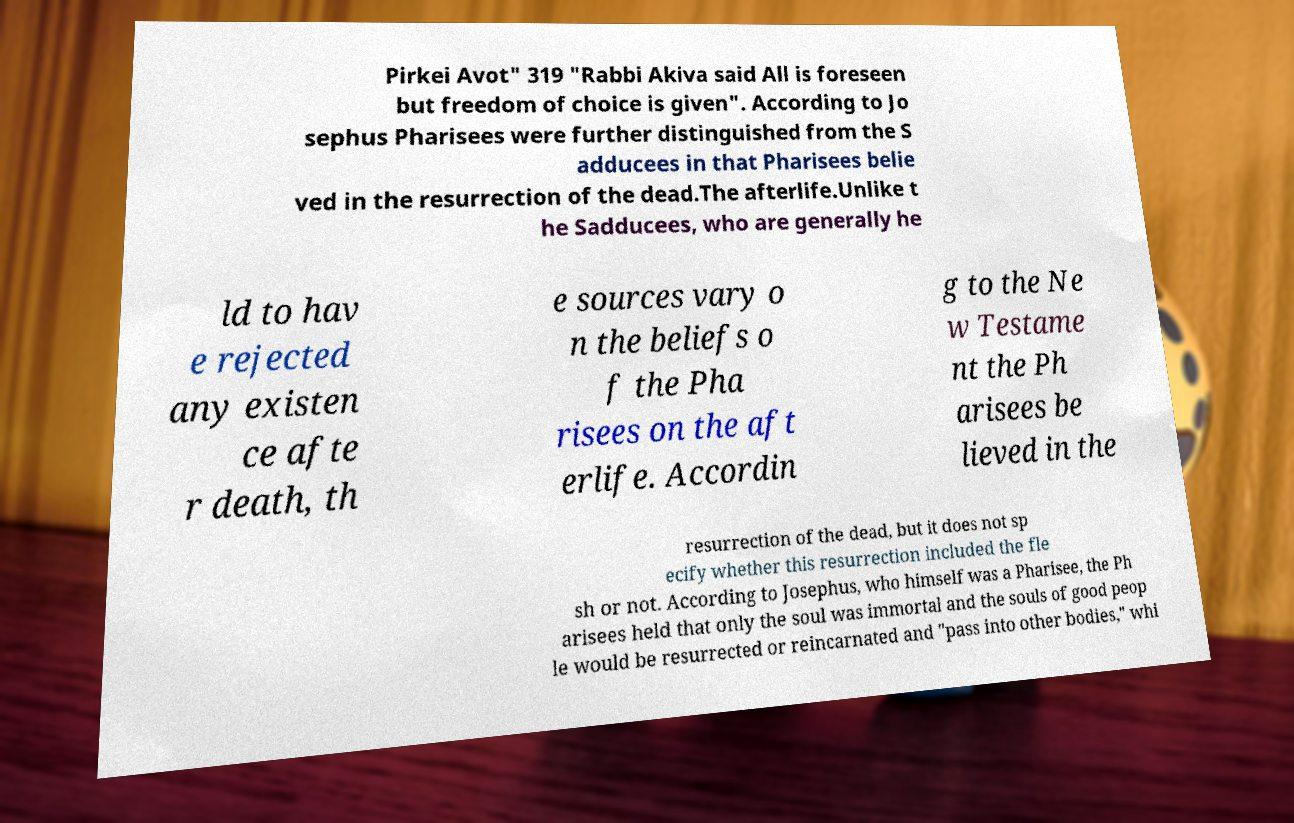I need the written content from this picture converted into text. Can you do that? Pirkei Avot" 319 "Rabbi Akiva said All is foreseen but freedom of choice is given". According to Jo sephus Pharisees were further distinguished from the S adducees in that Pharisees belie ved in the resurrection of the dead.The afterlife.Unlike t he Sadducees, who are generally he ld to hav e rejected any existen ce afte r death, th e sources vary o n the beliefs o f the Pha risees on the aft erlife. Accordin g to the Ne w Testame nt the Ph arisees be lieved in the resurrection of the dead, but it does not sp ecify whether this resurrection included the fle sh or not. According to Josephus, who himself was a Pharisee, the Ph arisees held that only the soul was immortal and the souls of good peop le would be resurrected or reincarnated and "pass into other bodies," whi 